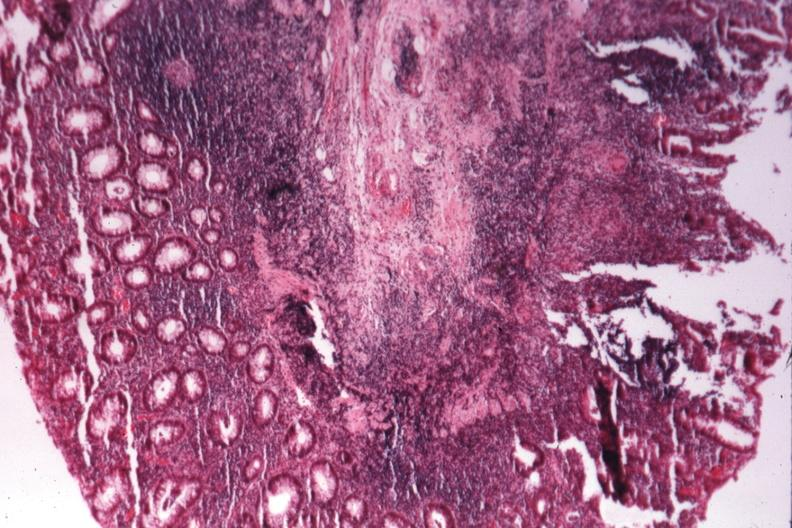s colon present?
Answer the question using a single word or phrase. Yes 